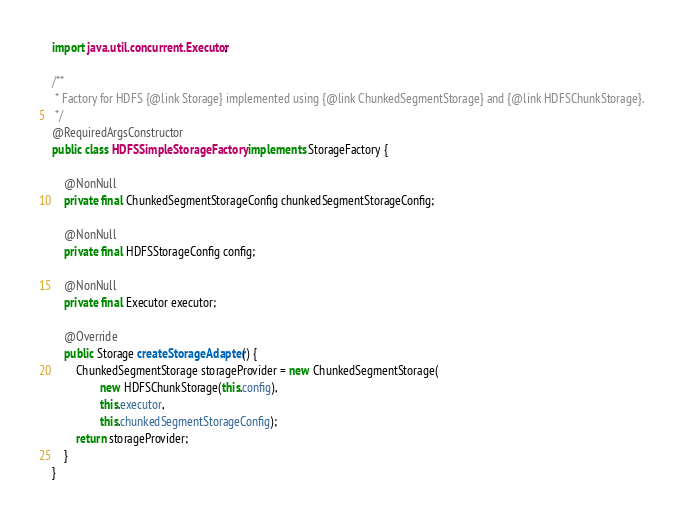<code> <loc_0><loc_0><loc_500><loc_500><_Java_>import java.util.concurrent.Executor;

/**
 * Factory for HDFS {@link Storage} implemented using {@link ChunkedSegmentStorage} and {@link HDFSChunkStorage}.
 */
@RequiredArgsConstructor
public class HDFSSimpleStorageFactory implements StorageFactory {

    @NonNull
    private final ChunkedSegmentStorageConfig chunkedSegmentStorageConfig;

    @NonNull
    private final HDFSStorageConfig config;

    @NonNull
    private final Executor executor;

    @Override
    public Storage createStorageAdapter() {
        ChunkedSegmentStorage storageProvider = new ChunkedSegmentStorage(
                new HDFSChunkStorage(this.config),
                this.executor,
                this.chunkedSegmentStorageConfig);
        return storageProvider;
    }
}
</code> 